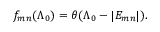Convert formula to latex. <formula><loc_0><loc_0><loc_500><loc_500>f _ { m n } ( \Lambda _ { 0 } ) = \theta ( \Lambda _ { 0 } - | E _ { m n } | ) .</formula> 